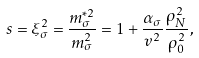<formula> <loc_0><loc_0><loc_500><loc_500>s = \xi _ { \sigma } ^ { 2 } = \frac { m _ { \sigma } ^ { * 2 } } { m _ { \sigma } ^ { 2 } } = 1 + \frac { \alpha _ { \sigma } } { v ^ { 2 } } \frac { \rho _ { N } ^ { 2 } } { \rho _ { 0 } ^ { 2 } } ,</formula> 